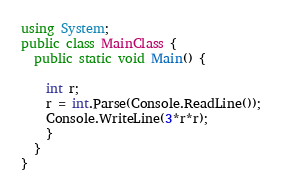<code> <loc_0><loc_0><loc_500><loc_500><_C#_>using System;
public class MainClass {
  public static void Main() {
    
    int r;
    r = int.Parse(Console.ReadLine());
    Console.WriteLine(3*r*r);
    }
  }
}</code> 